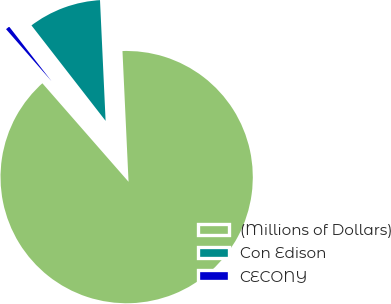Convert chart. <chart><loc_0><loc_0><loc_500><loc_500><pie_chart><fcel>(Millions of Dollars)<fcel>Con Edison<fcel>CECONY<nl><fcel>89.3%<fcel>9.77%<fcel>0.93%<nl></chart> 